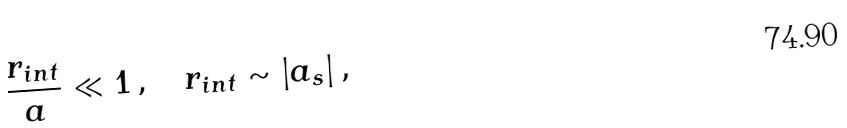<formula> <loc_0><loc_0><loc_500><loc_500>\frac { r _ { i n t } } { a } \ll 1 \, , \quad r _ { i n t } \sim | a _ { s } | \, ,</formula> 